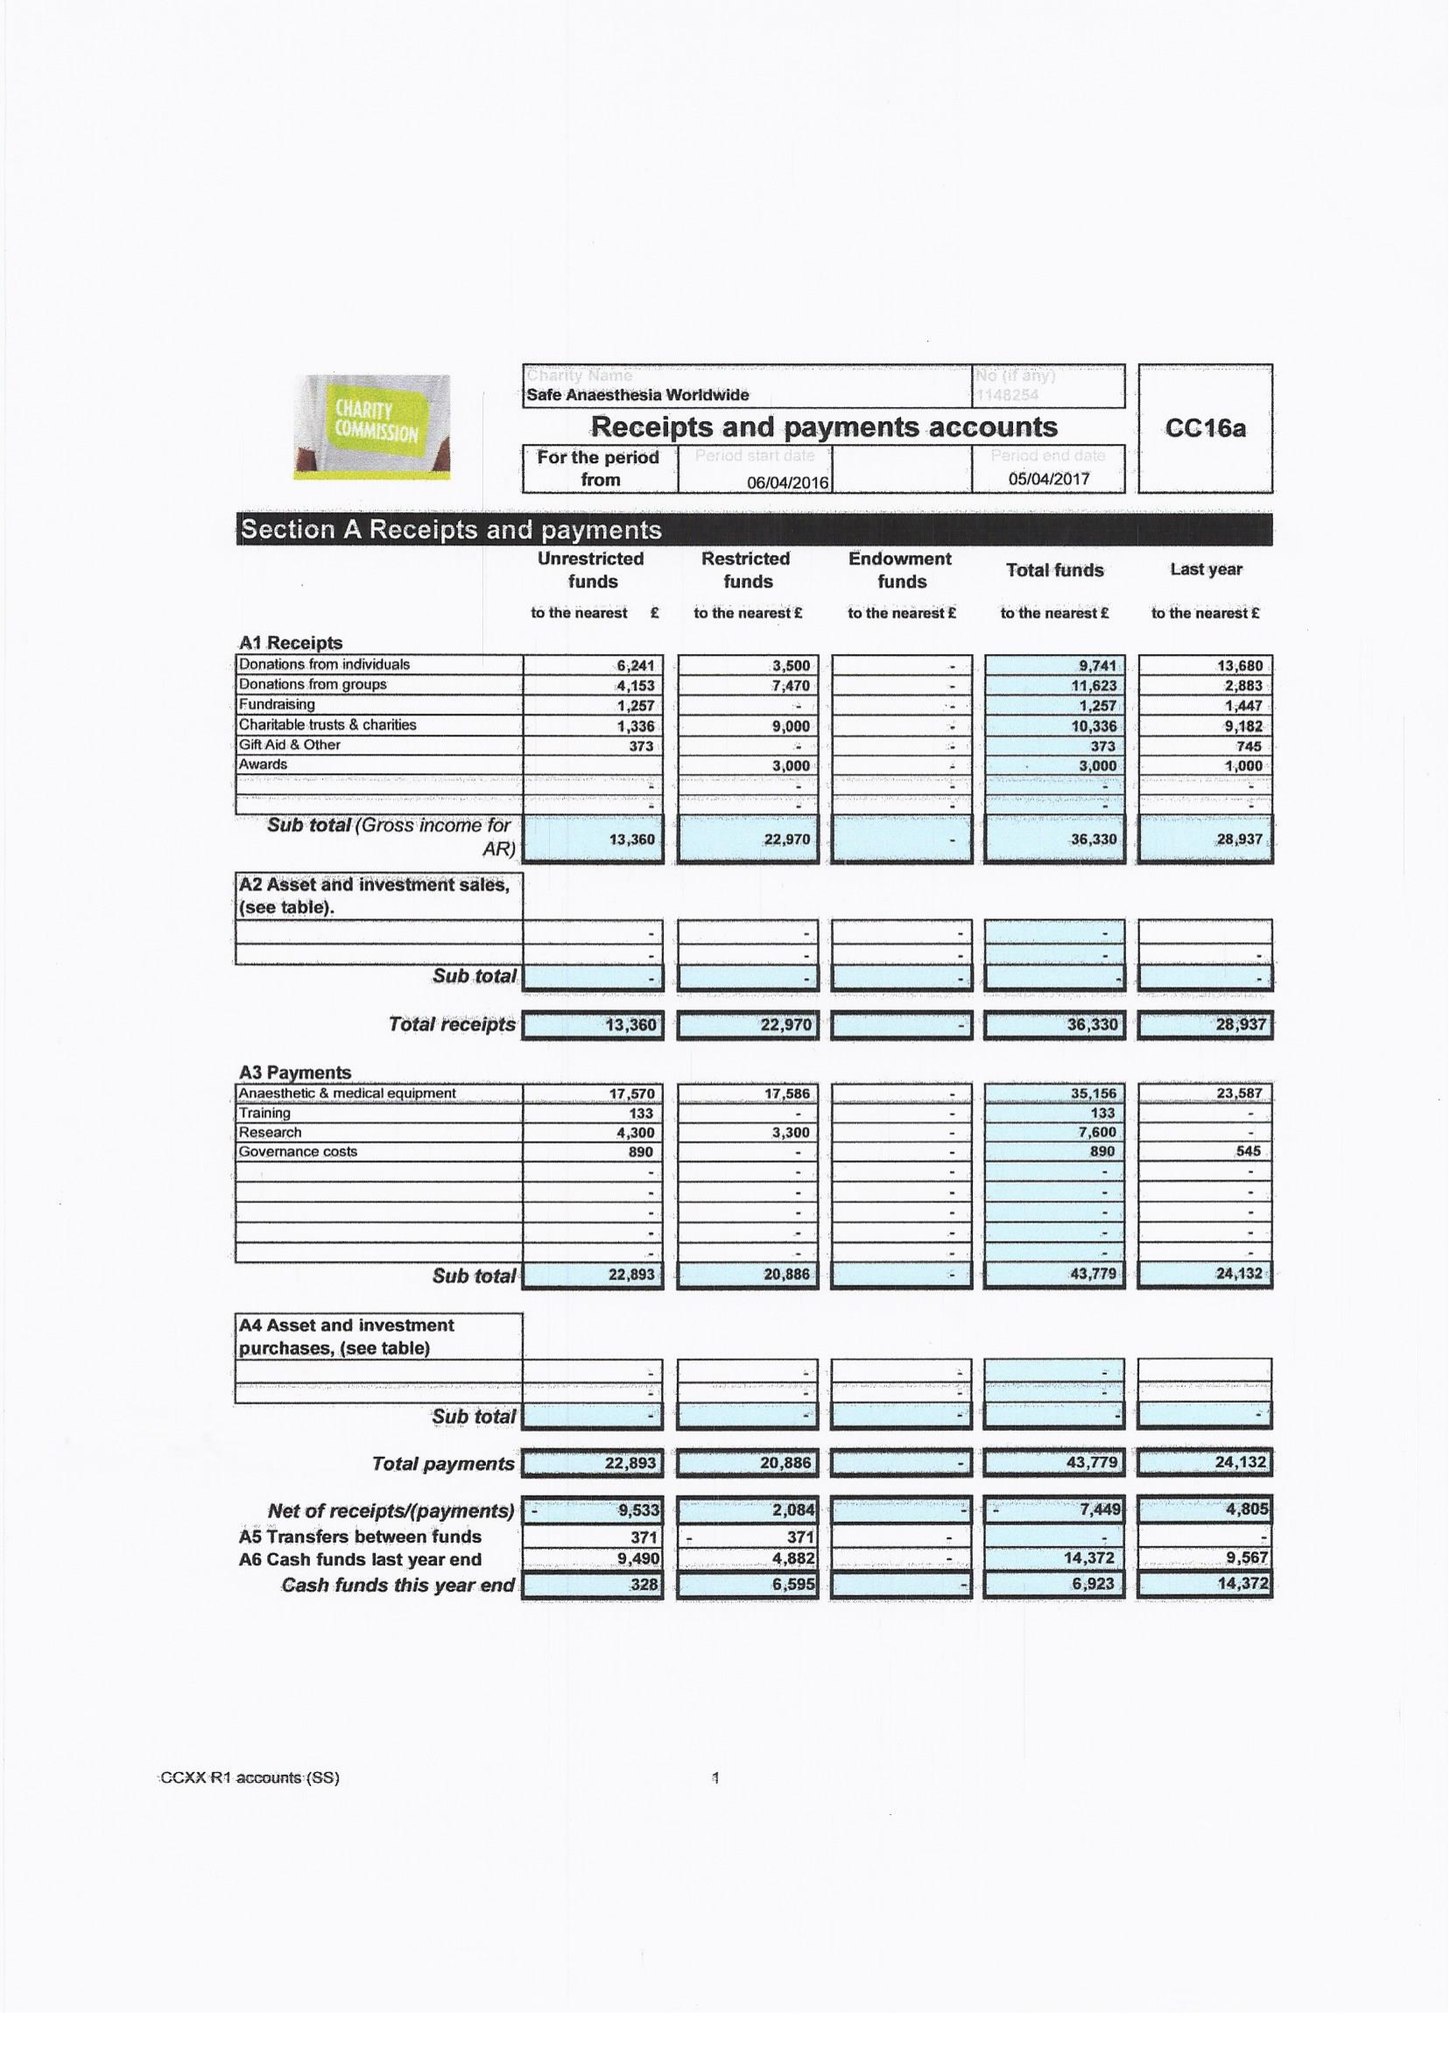What is the value for the charity_number?
Answer the question using a single word or phrase. 1148254 